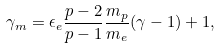Convert formula to latex. <formula><loc_0><loc_0><loc_500><loc_500>\gamma _ { m } = \epsilon _ { e } \frac { p - 2 } { p - 1 } \frac { m _ { p } } { m _ { e } } ( \gamma - 1 ) + 1 ,</formula> 